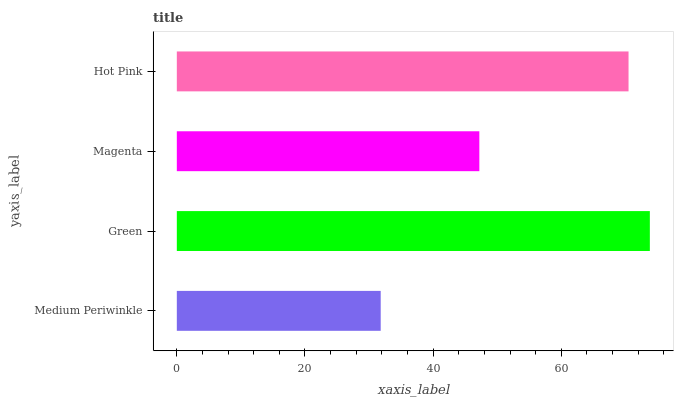Is Medium Periwinkle the minimum?
Answer yes or no. Yes. Is Green the maximum?
Answer yes or no. Yes. Is Magenta the minimum?
Answer yes or no. No. Is Magenta the maximum?
Answer yes or no. No. Is Green greater than Magenta?
Answer yes or no. Yes. Is Magenta less than Green?
Answer yes or no. Yes. Is Magenta greater than Green?
Answer yes or no. No. Is Green less than Magenta?
Answer yes or no. No. Is Hot Pink the high median?
Answer yes or no. Yes. Is Magenta the low median?
Answer yes or no. Yes. Is Magenta the high median?
Answer yes or no. No. Is Medium Periwinkle the low median?
Answer yes or no. No. 